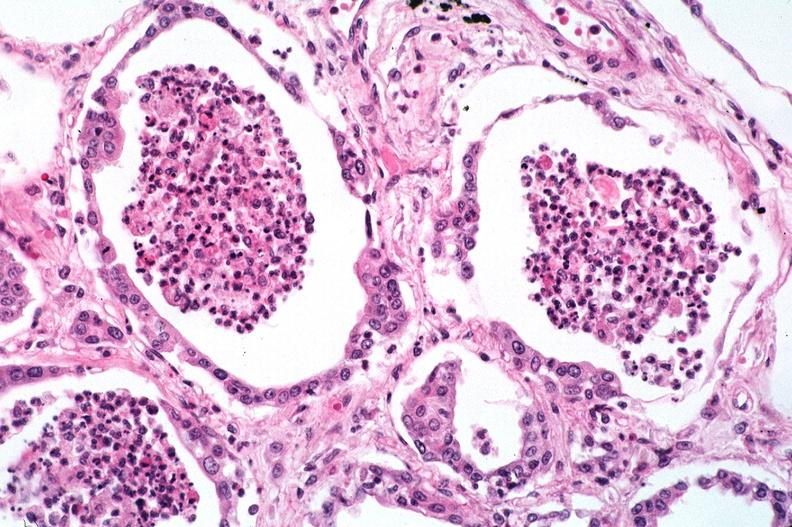s respiratory present?
Answer the question using a single word or phrase. Yes 